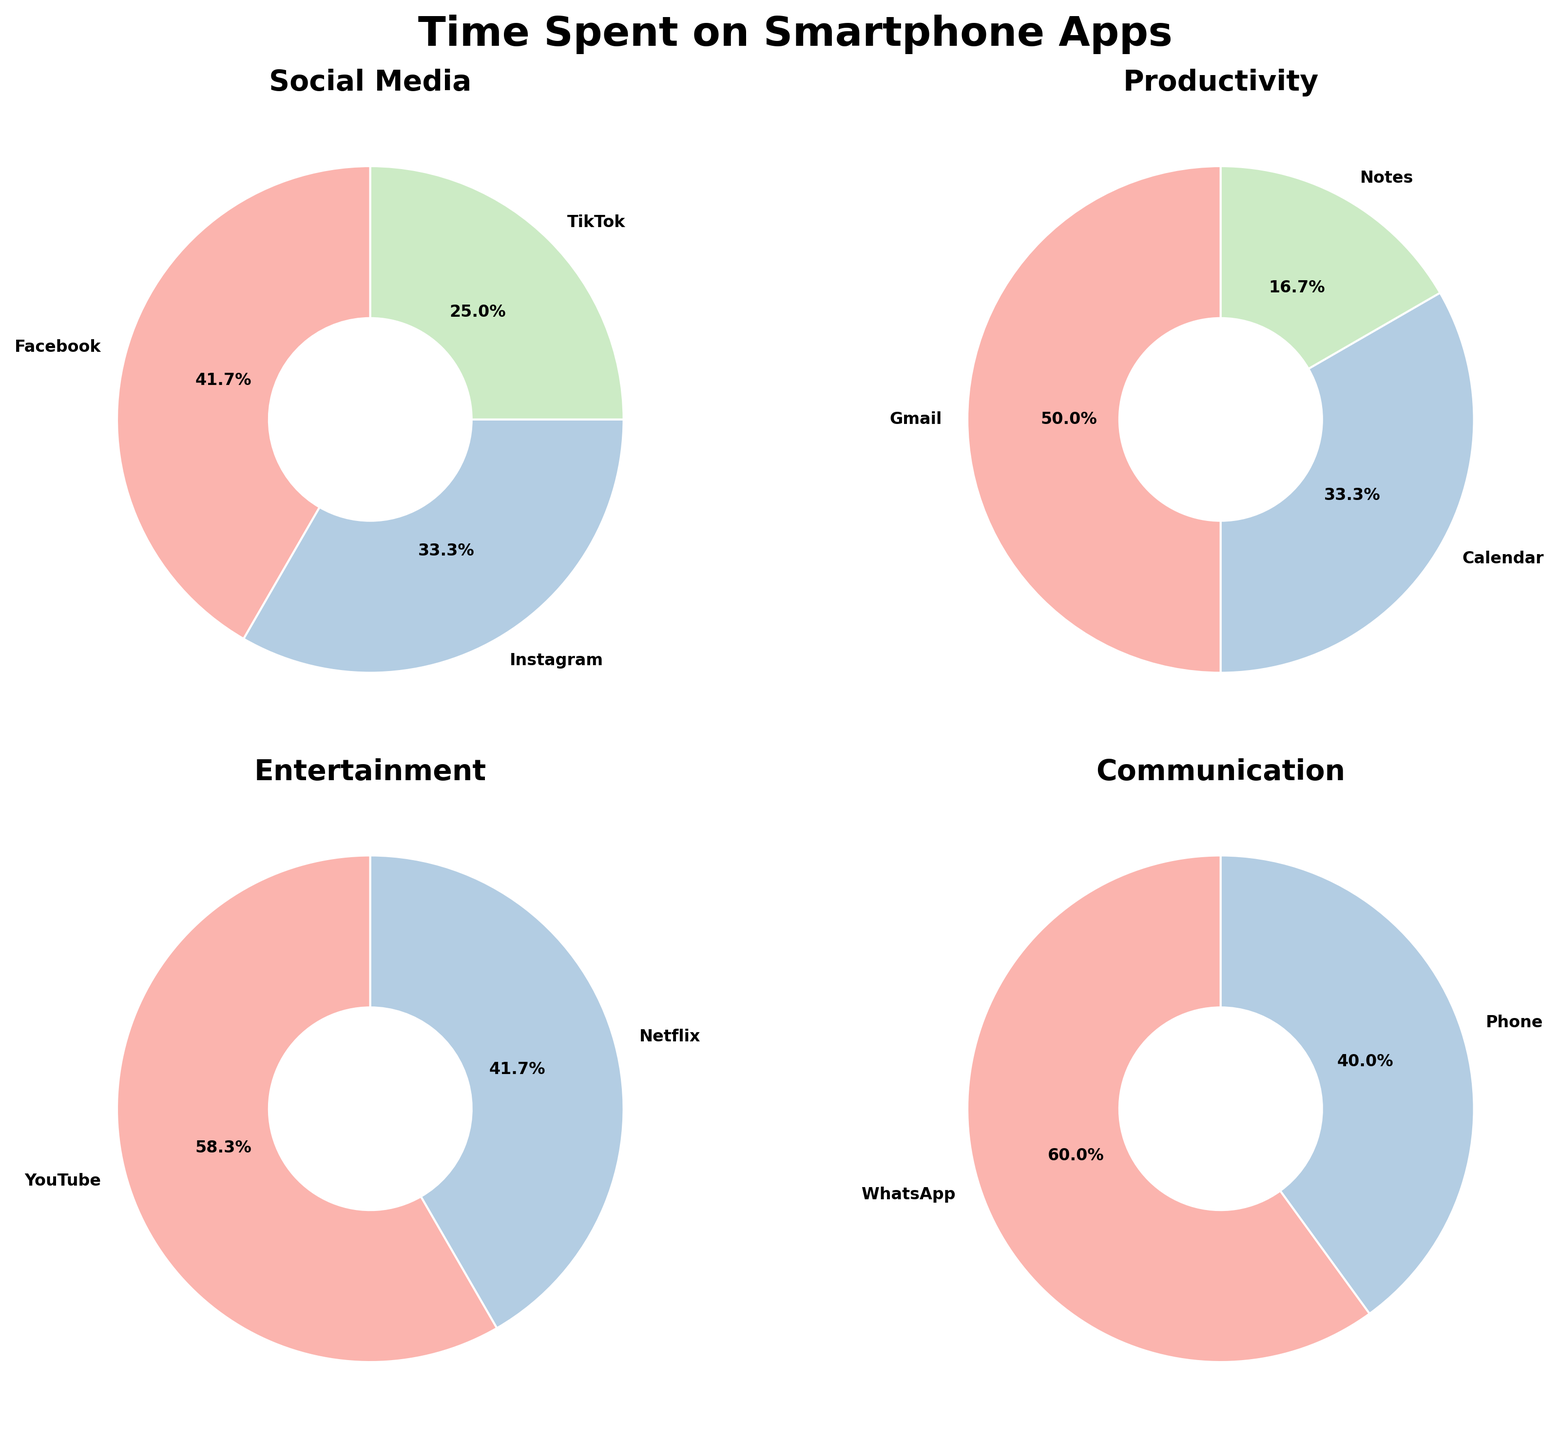What is the title of the figure? The title is centrally placed at the top of the figure. It reads 'Time Spent on Smartphone Apps' in a bold and larger font size.
Answer: Time Spent on Smartphone Apps Which category has the largest proportion of time spent in the 'Social Media' pie chart? By looking at the 'Social Media' pie chart, the largest section is labeled 'Facebook'.
Answer: Facebook How much time is spent in total on 'Communication' apps? Summing up the percentages in the 'Communication' pie chart: WhatsApp (30%) and Phone (20%) total to 50%.
Answer: 50% Which app is used the most under 'Productivity'? In the 'Productivity' pie chart, Gmail has the largest section with 15%.
Answer: Gmail What is the sum of the allocated times for 'YouTube' and 'Netflix' under 'Entertainment'? By summing the values from the 'Entertainment' pie chart: YouTube (35%) and Netflix (25%), it equals 60%.
Answer: 60% Between 'Calendar' and 'Notes', which app uses more time under 'Productivity'? In the 'Productivity' pie chart, the 'Calendar' slice is larger than the 'Notes' slice.
Answer: Calendar How do the times spent on YouTube and Notes compare? Comparing the 'Entertainment' and 'Productivity' pie charts, YouTube is 35%, and Notes is 5%, so YouTube has more time spent.
Answer: YouTube Which app has the smallest proportion of time in the 'Entertainment' category? In the 'Entertainment' pie chart, the smallest slice is for Netflix.
Answer: Netflix What percentage of time is spent on Instagram under 'Social Media'? The 'Social Media' pie chart shows Instagram occupies 20% of the total time.
Answer: 20% Which category has the highest number of apps shown in the pie charts? Count the apps in each pie chart: 'Social Media' (3 apps), 'Productivity' (3 apps), 'Entertainment' (2 apps), 'Communication' (2 apps). The first two have the highest number of apps, hence:
Answer: Social Media and Productivity 